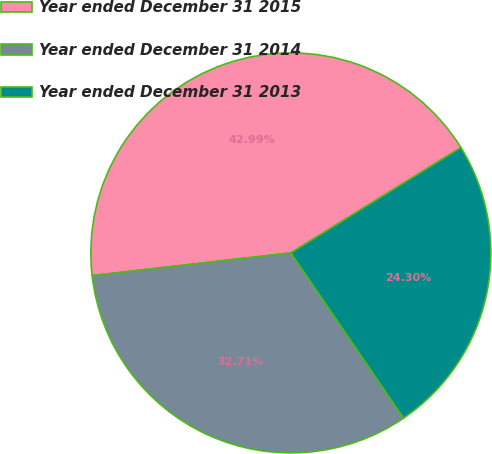<chart> <loc_0><loc_0><loc_500><loc_500><pie_chart><fcel>Year ended December 31 2015<fcel>Year ended December 31 2014<fcel>Year ended December 31 2013<nl><fcel>42.99%<fcel>32.71%<fcel>24.3%<nl></chart> 